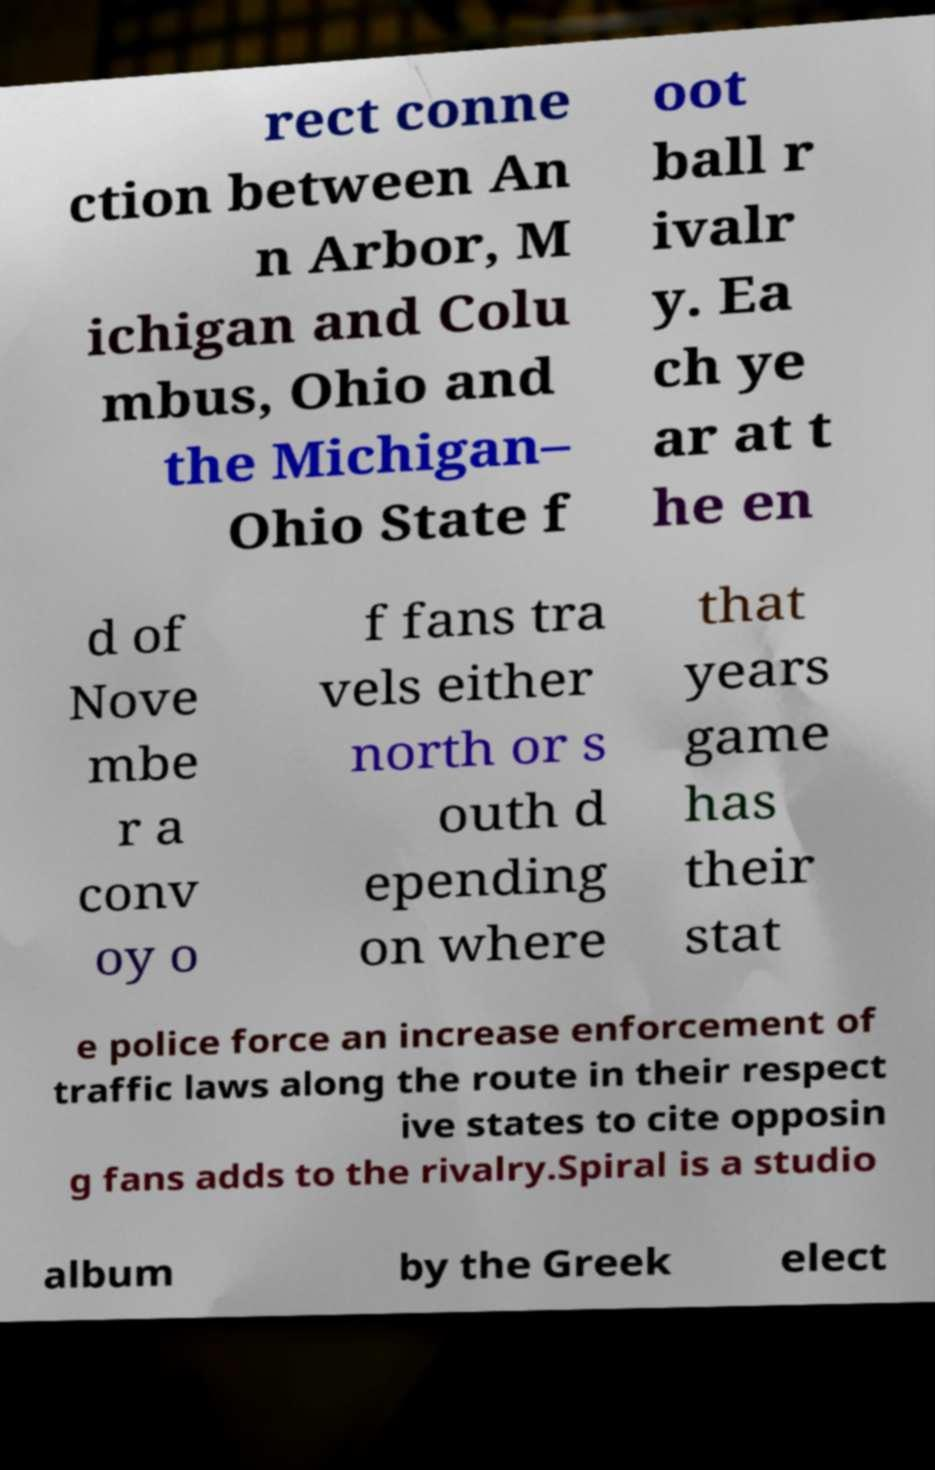Can you accurately transcribe the text from the provided image for me? rect conne ction between An n Arbor, M ichigan and Colu mbus, Ohio and the Michigan– Ohio State f oot ball r ivalr y. Ea ch ye ar at t he en d of Nove mbe r a conv oy o f fans tra vels either north or s outh d epending on where that years game has their stat e police force an increase enforcement of traffic laws along the route in their respect ive states to cite opposin g fans adds to the rivalry.Spiral is a studio album by the Greek elect 